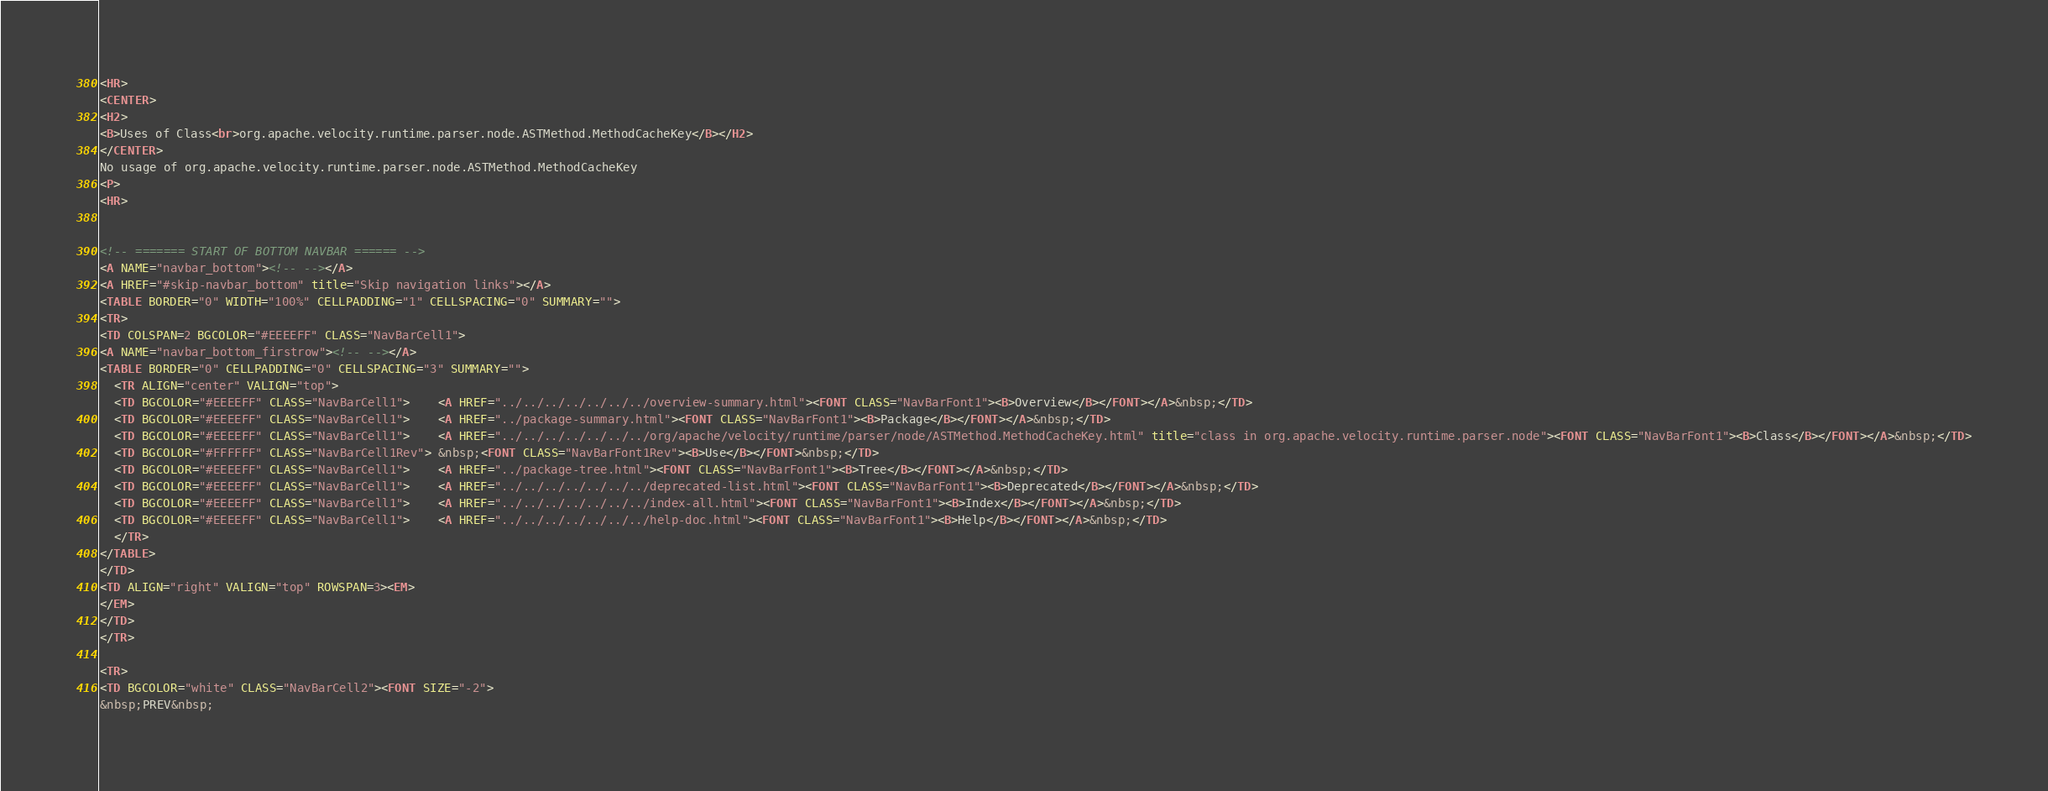<code> <loc_0><loc_0><loc_500><loc_500><_HTML_>
<HR>
<CENTER>
<H2>
<B>Uses of Class<br>org.apache.velocity.runtime.parser.node.ASTMethod.MethodCacheKey</B></H2>
</CENTER>
No usage of org.apache.velocity.runtime.parser.node.ASTMethod.MethodCacheKey
<P>
<HR>


<!-- ======= START OF BOTTOM NAVBAR ====== -->
<A NAME="navbar_bottom"><!-- --></A>
<A HREF="#skip-navbar_bottom" title="Skip navigation links"></A>
<TABLE BORDER="0" WIDTH="100%" CELLPADDING="1" CELLSPACING="0" SUMMARY="">
<TR>
<TD COLSPAN=2 BGCOLOR="#EEEEFF" CLASS="NavBarCell1">
<A NAME="navbar_bottom_firstrow"><!-- --></A>
<TABLE BORDER="0" CELLPADDING="0" CELLSPACING="3" SUMMARY="">
  <TR ALIGN="center" VALIGN="top">
  <TD BGCOLOR="#EEEEFF" CLASS="NavBarCell1">    <A HREF="../../../../../../../overview-summary.html"><FONT CLASS="NavBarFont1"><B>Overview</B></FONT></A>&nbsp;</TD>
  <TD BGCOLOR="#EEEEFF" CLASS="NavBarCell1">    <A HREF="../package-summary.html"><FONT CLASS="NavBarFont1"><B>Package</B></FONT></A>&nbsp;</TD>
  <TD BGCOLOR="#EEEEFF" CLASS="NavBarCell1">    <A HREF="../../../../../../../org/apache/velocity/runtime/parser/node/ASTMethod.MethodCacheKey.html" title="class in org.apache.velocity.runtime.parser.node"><FONT CLASS="NavBarFont1"><B>Class</B></FONT></A>&nbsp;</TD>
  <TD BGCOLOR="#FFFFFF" CLASS="NavBarCell1Rev"> &nbsp;<FONT CLASS="NavBarFont1Rev"><B>Use</B></FONT>&nbsp;</TD>
  <TD BGCOLOR="#EEEEFF" CLASS="NavBarCell1">    <A HREF="../package-tree.html"><FONT CLASS="NavBarFont1"><B>Tree</B></FONT></A>&nbsp;</TD>
  <TD BGCOLOR="#EEEEFF" CLASS="NavBarCell1">    <A HREF="../../../../../../../deprecated-list.html"><FONT CLASS="NavBarFont1"><B>Deprecated</B></FONT></A>&nbsp;</TD>
  <TD BGCOLOR="#EEEEFF" CLASS="NavBarCell1">    <A HREF="../../../../../../../index-all.html"><FONT CLASS="NavBarFont1"><B>Index</B></FONT></A>&nbsp;</TD>
  <TD BGCOLOR="#EEEEFF" CLASS="NavBarCell1">    <A HREF="../../../../../../../help-doc.html"><FONT CLASS="NavBarFont1"><B>Help</B></FONT></A>&nbsp;</TD>
  </TR>
</TABLE>
</TD>
<TD ALIGN="right" VALIGN="top" ROWSPAN=3><EM>
</EM>
</TD>
</TR>

<TR>
<TD BGCOLOR="white" CLASS="NavBarCell2"><FONT SIZE="-2">
&nbsp;PREV&nbsp;</code> 